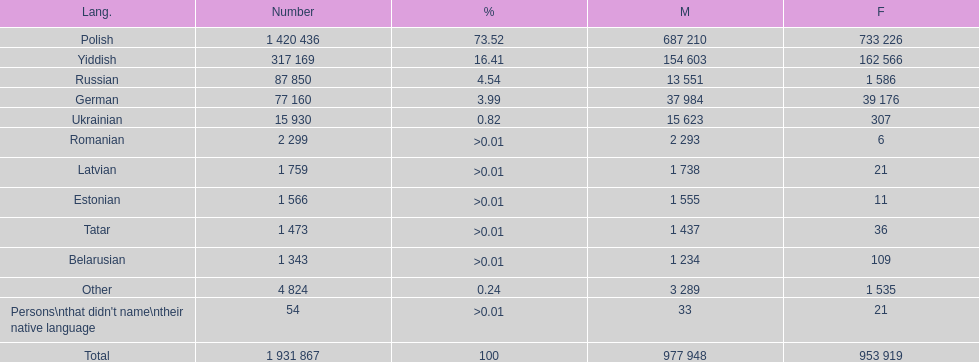Can you give me this table as a dict? {'header': ['Lang.', 'Number', '%', 'M', 'F'], 'rows': [['Polish', '1 420 436', '73.52', '687 210', '733 226'], ['Yiddish', '317 169', '16.41', '154 603', '162 566'], ['Russian', '87 850', '4.54', '13 551', '1 586'], ['German', '77 160', '3.99', '37 984', '39 176'], ['Ukrainian', '15 930', '0.82', '15 623', '307'], ['Romanian', '2 299', '>0.01', '2 293', '6'], ['Latvian', '1 759', '>0.01', '1 738', '21'], ['Estonian', '1 566', '>0.01', '1 555', '11'], ['Tatar', '1 473', '>0.01', '1 437', '36'], ['Belarusian', '1 343', '>0.01', '1 234', '109'], ['Other', '4 824', '0.24', '3 289', '1 535'], ["Persons\\nthat didn't name\\ntheir native language", '54', '>0.01', '33', '21'], ['Total', '1 931 867', '100', '977 948', '953 919']]} Which language had the fewest female speakers? Romanian. 